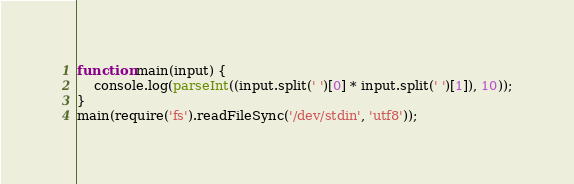Convert code to text. <code><loc_0><loc_0><loc_500><loc_500><_JavaScript_>function main(input) {
    console.log(parseInt((input.split(' ')[0] * input.split(' ')[1]), 10));
}
main(require('fs').readFileSync('/dev/stdin', 'utf8'));</code> 